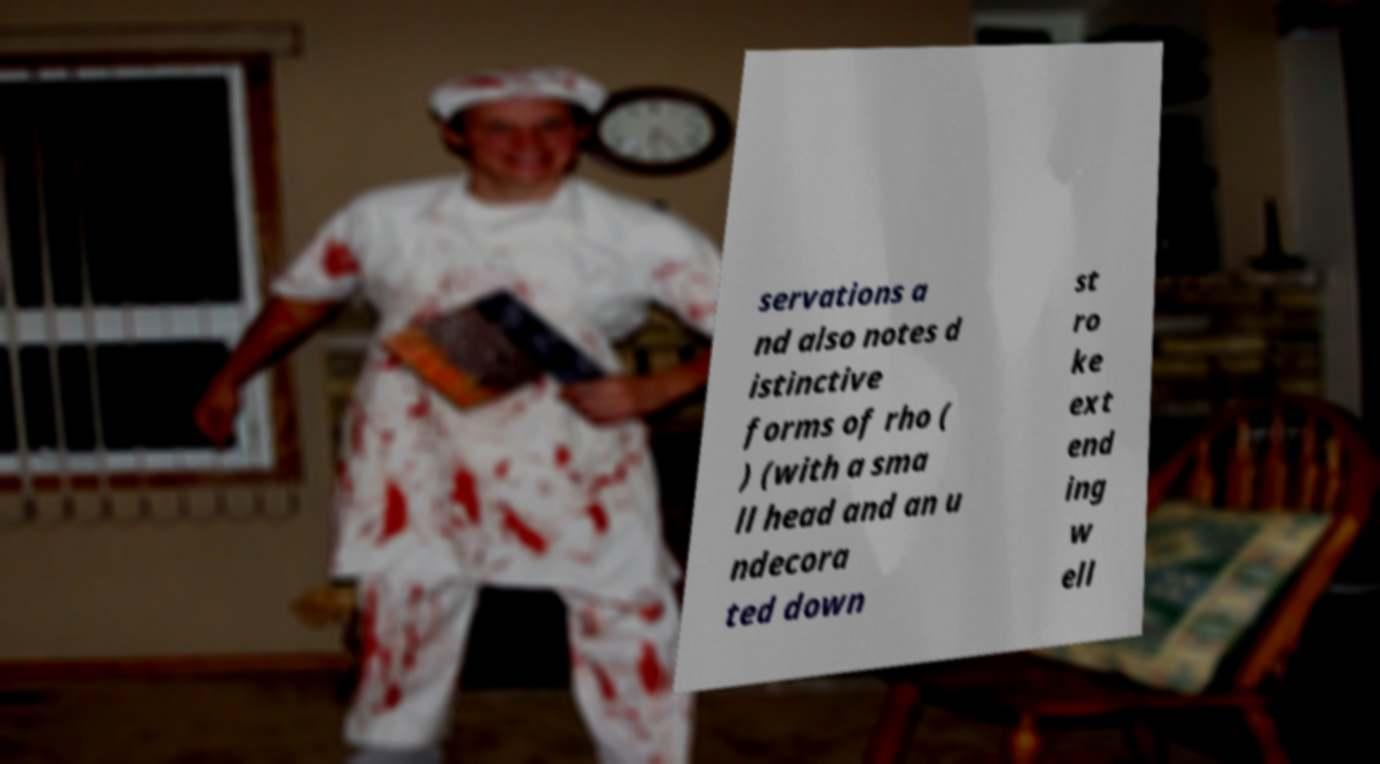There's text embedded in this image that I need extracted. Can you transcribe it verbatim? servations a nd also notes d istinctive forms of rho ( ) (with a sma ll head and an u ndecora ted down st ro ke ext end ing w ell 